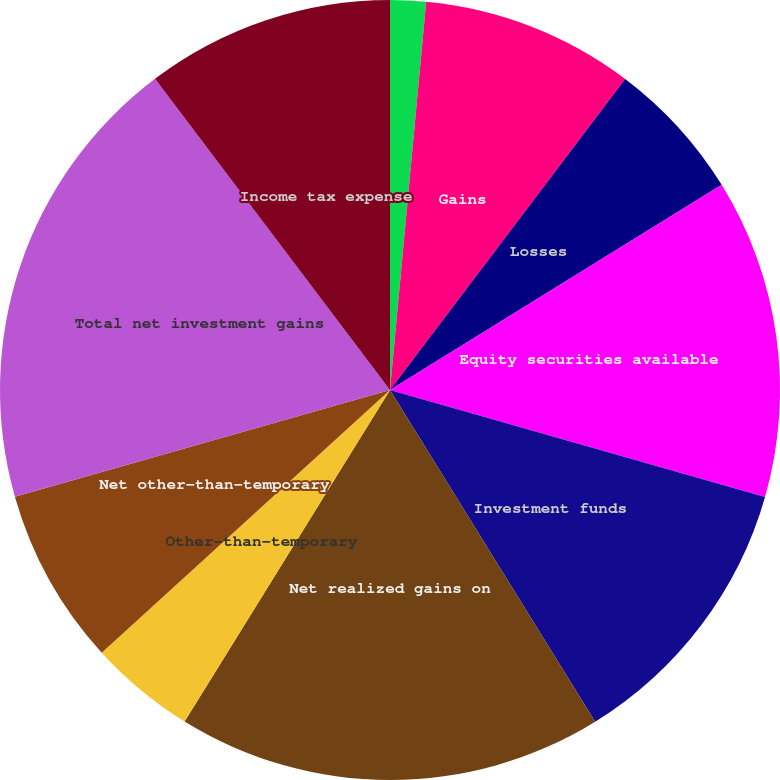Convert chart to OTSL. <chart><loc_0><loc_0><loc_500><loc_500><pie_chart><fcel>(In thousands)<fcel>Gains<fcel>Losses<fcel>Equity securities available<fcel>Investment funds<fcel>Net realized gains on<fcel>Other-than-temporary<fcel>Net other-than-temporary<fcel>Total net investment gains<fcel>Income tax expense<nl><fcel>1.48%<fcel>8.82%<fcel>5.88%<fcel>13.23%<fcel>11.76%<fcel>17.64%<fcel>4.41%<fcel>7.35%<fcel>19.11%<fcel>10.29%<nl></chart> 